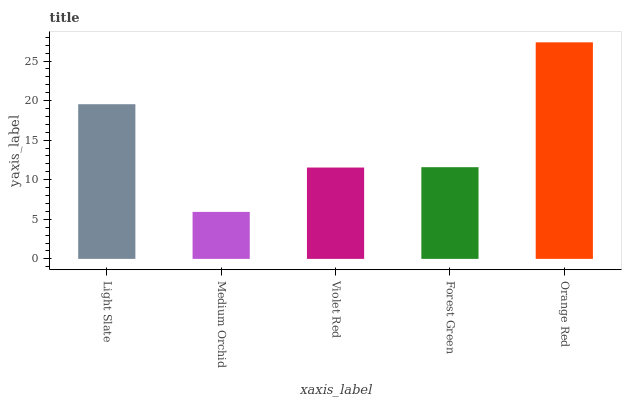Is Violet Red the minimum?
Answer yes or no. No. Is Violet Red the maximum?
Answer yes or no. No. Is Violet Red greater than Medium Orchid?
Answer yes or no. Yes. Is Medium Orchid less than Violet Red?
Answer yes or no. Yes. Is Medium Orchid greater than Violet Red?
Answer yes or no. No. Is Violet Red less than Medium Orchid?
Answer yes or no. No. Is Forest Green the high median?
Answer yes or no. Yes. Is Forest Green the low median?
Answer yes or no. Yes. Is Light Slate the high median?
Answer yes or no. No. Is Medium Orchid the low median?
Answer yes or no. No. 